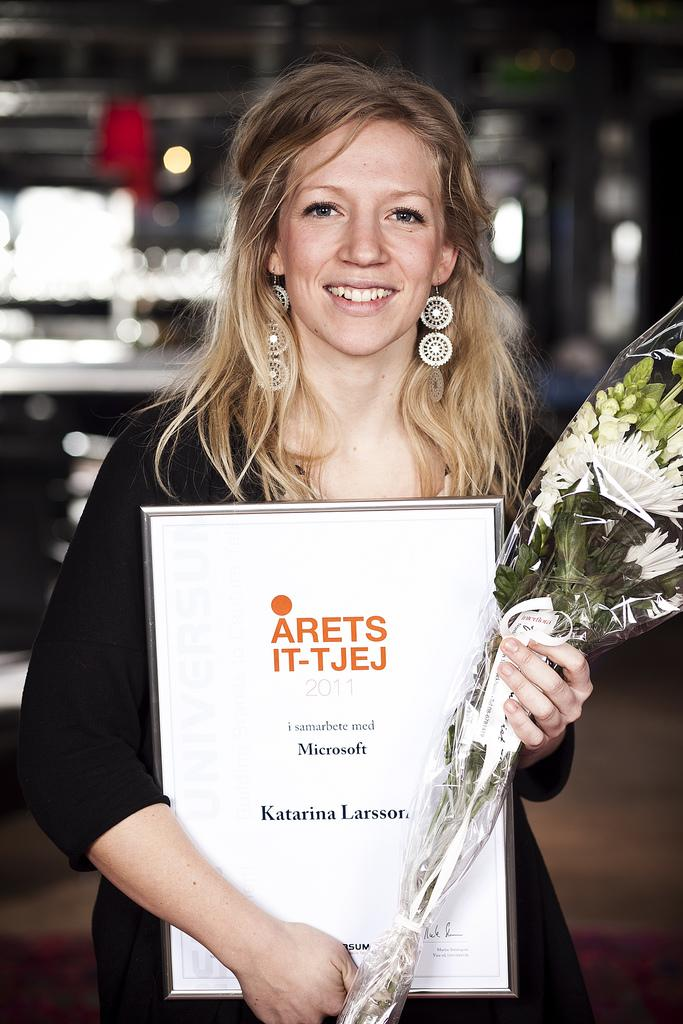What is the person in the image holding? The person is holding a frame and a bouquet in the image. What else can be seen in the image besides the person and their items? There are other objects visible in the image. Can you describe the background of the image? The background of the image is blurred. What type of insurance policy is being discussed in the image? There is no mention of insurance in the image; it features a person holding a frame and a bouquet. Can you describe the door in the image? There is no door present in the image. 